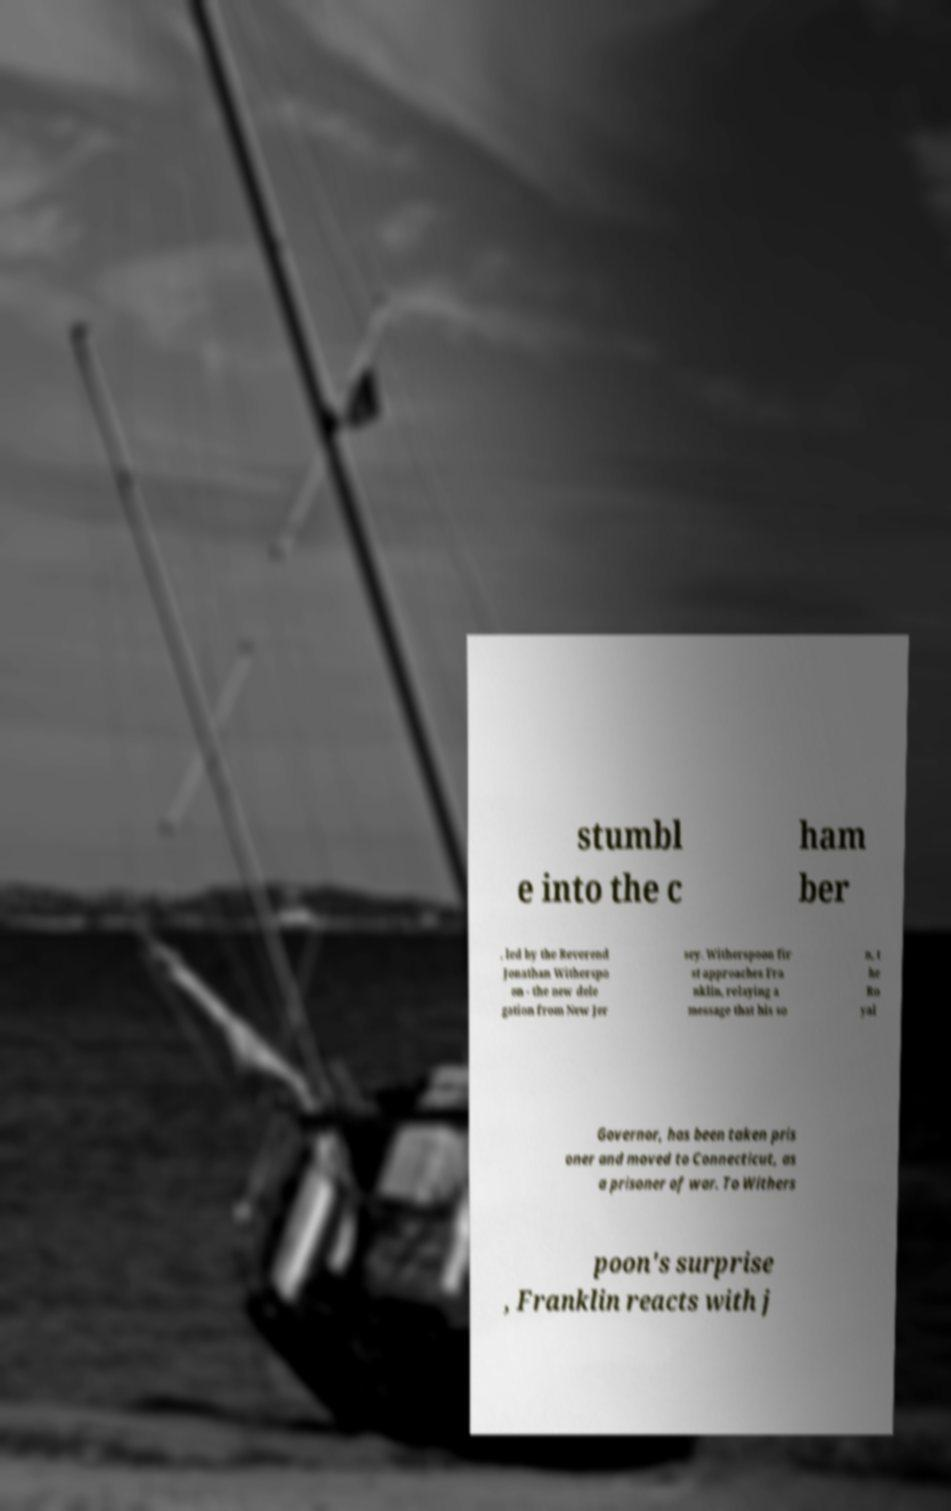Could you extract and type out the text from this image? stumbl e into the c ham ber , led by the Reverend Jonathan Witherspo on - the new dele gation from New Jer sey. Witherspoon fir st approaches Fra nklin, relaying a message that his so n, t he Ro yal Governor, has been taken pris oner and moved to Connecticut, as a prisoner of war. To Withers poon's surprise , Franklin reacts with j 